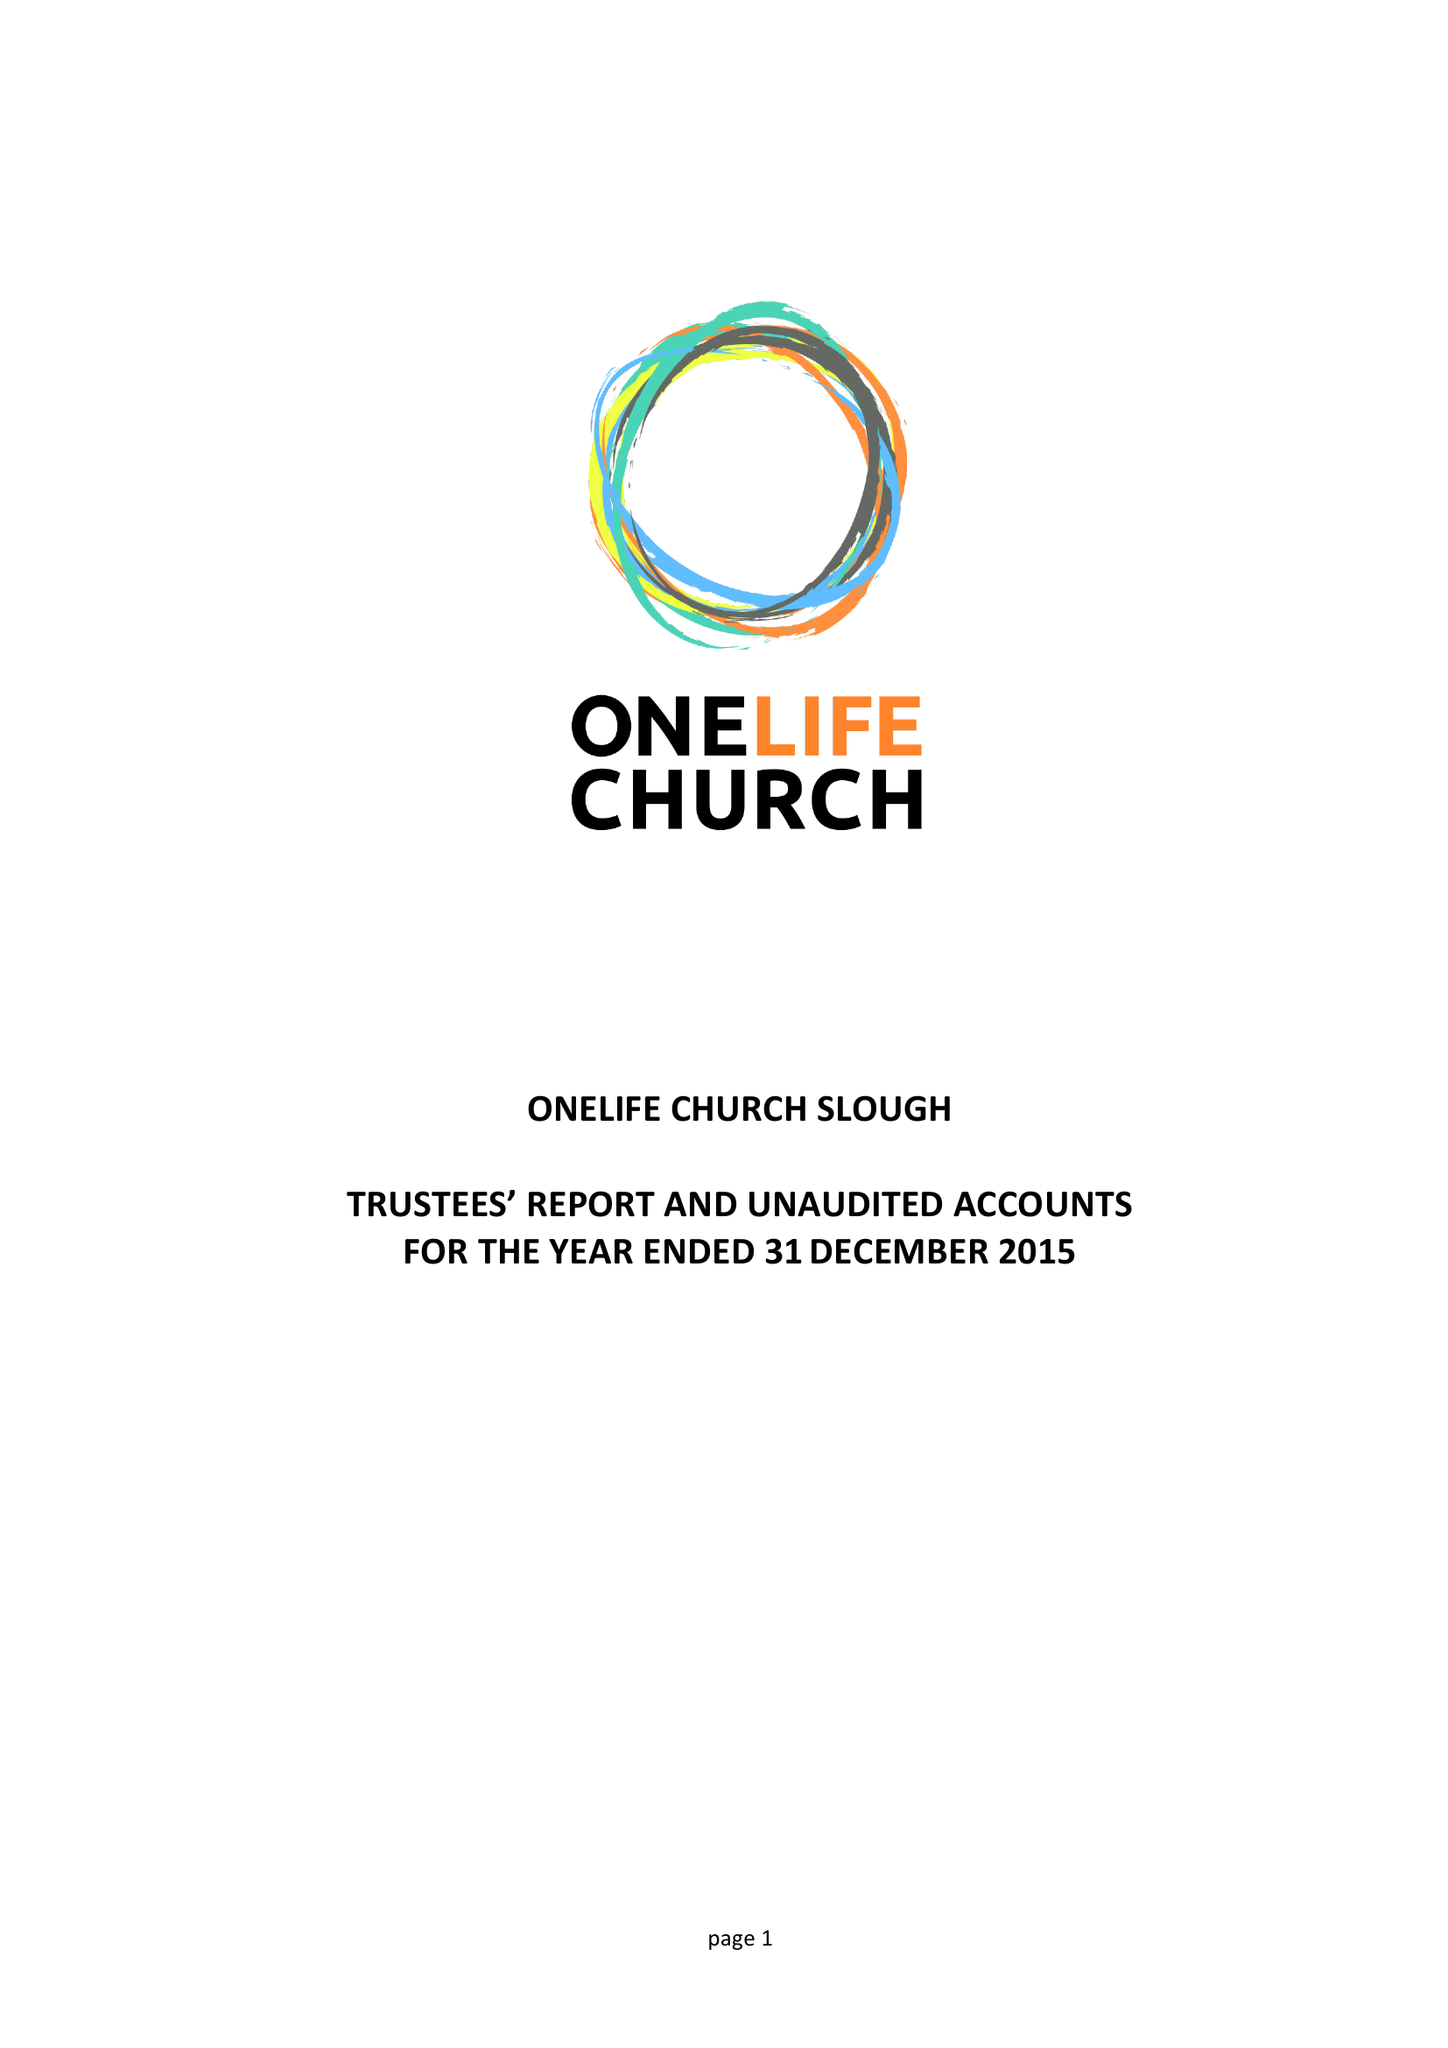What is the value for the charity_number?
Answer the question using a single word or phrase. 1156309 